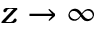Convert formula to latex. <formula><loc_0><loc_0><loc_500><loc_500>z \to \infty</formula> 